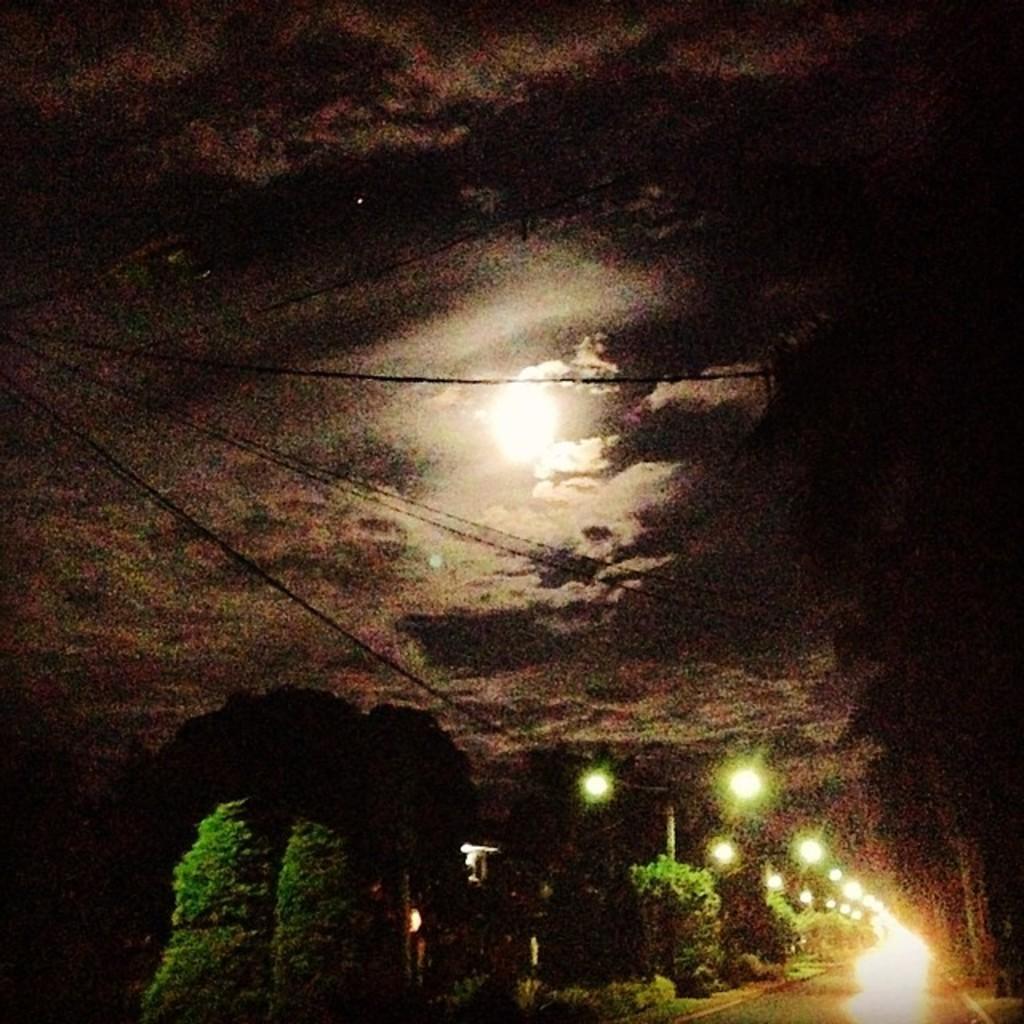Could you give a brief overview of what you see in this image? In this image in the bottom right hand corner there is a road and in the middle there is a moon and background is the sky. 